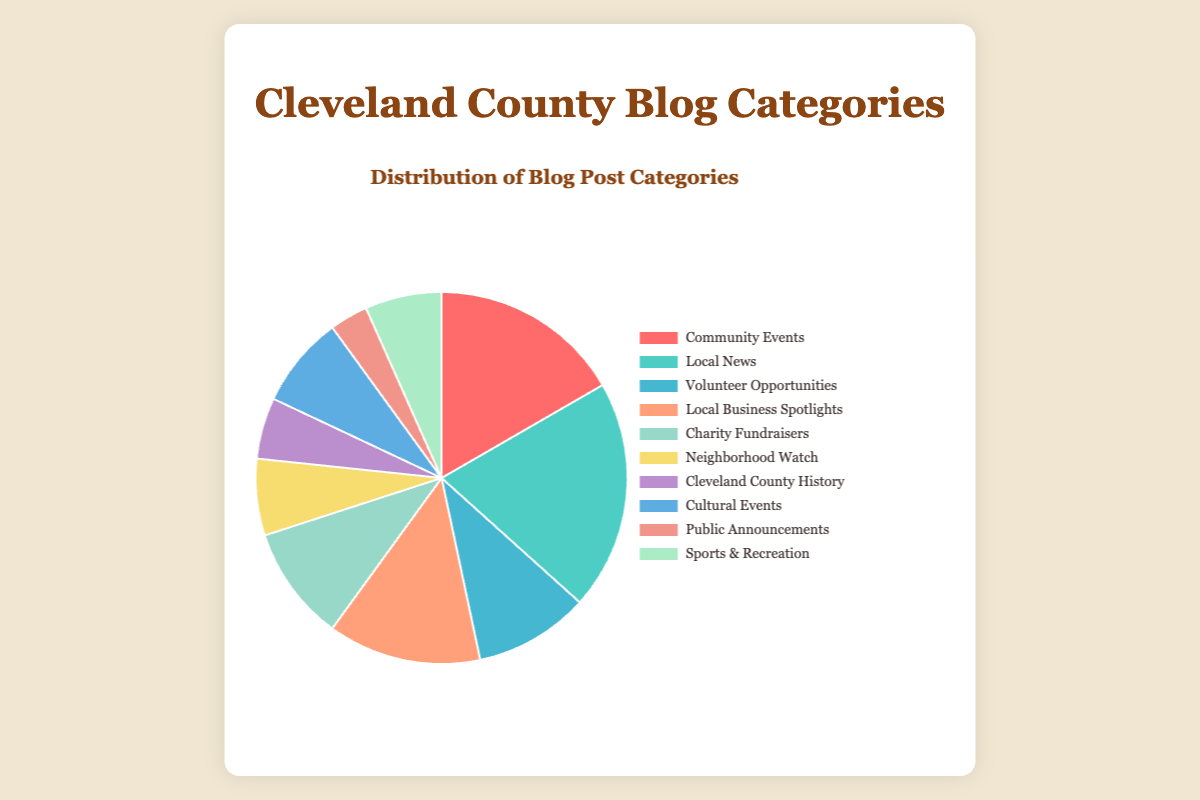How many more posts are there in the 'Local News' category compared to the 'Public Announcements' category? To find the difference in the number of posts between 'Local News' and 'Public Announcements', subtract the number of 'Public Announcements' posts from the 'Local News' posts, which is 30 - 5.
Answer: 25 Which category has the highest number of posts and what is the total number of posts in that category? The category with the highest number of posts can be identified by looking at the segment with the largest portion in the pie chart. In this case, it is 'Local News' with 30 posts.
Answer: Local News, 30 What is the total number of posts for 'Community Events' and 'Charity Fundraisers' combined? Add the number of posts for 'Community Events' and 'Charity Fundraisers': 25 (Community Events) + 15 (Charity Fundraisers) = 40.
Answer: 40 What percentage of the total posts does the 'Neighborhood Watch' category represent? First, calculate the total number of posts by summing up all posts: (25 + 30 + 15 + 20 + 15 + 10 + 8 + 12 + 5 + 10) = 150. Then, divide the number of posts in the 'Neighborhood Watch' category by the total posts and multiply by 100: (10 / 150) * 100 ≈ 6.67%.
Answer: 6.67% Between 'Volunteer Opportunities' and 'Cultural Events', which category has fewer posts and by how many? Compare the number of posts in 'Volunteer Opportunities' and 'Cultural Events'. 'Volunteer Opportunities' has 15 posts while 'Cultural Events' has 12 posts. The difference is 15 - 12 = 3.
Answer: Cultural Events, 3 What is the proportion of posts in 'Local Business Spotlights' relative to the total number of posts? Calculate the proportion by dividing the number of 'Local Business Spotlights' posts by the total number of posts: 20 / 150. This gives the proportion as approximately 0.1333, or 13.33%.
Answer: 13.33% Which color represents the 'Cleveland County History' category in the chart? Identify the segment corresponding to 'Cleveland County History' and note its color, which is visually indicated as purple.
Answer: purple How does the number of posts in 'Sports & Recreation' compare to 'Public Announcements'? Compare the number of posts in 'Sports & Recreation' (10) with those in 'Public Announcements' (5). Since 10 is greater than 5, 'Sports & Recreation' has more posts.
Answer: Sports & Recreation What is the average number of posts per category? Calculate the total number of posts and divide by the number of categories: 150 / 10 = 15.
Answer: 15 